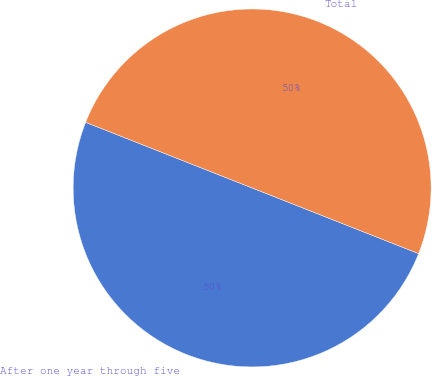Convert chart. <chart><loc_0><loc_0><loc_500><loc_500><pie_chart><fcel>After one year through five<fcel>Total<nl><fcel>50.0%<fcel>50.0%<nl></chart> 